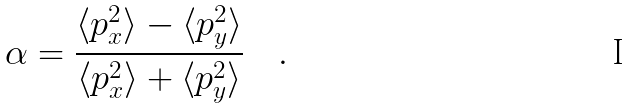<formula> <loc_0><loc_0><loc_500><loc_500>\alpha = \frac { \langle p _ { x } ^ { 2 } \rangle - \langle p _ { y } ^ { 2 } \rangle } { \langle p _ { x } ^ { 2 } \rangle + \langle p _ { y } ^ { 2 } \rangle } \quad .</formula> 